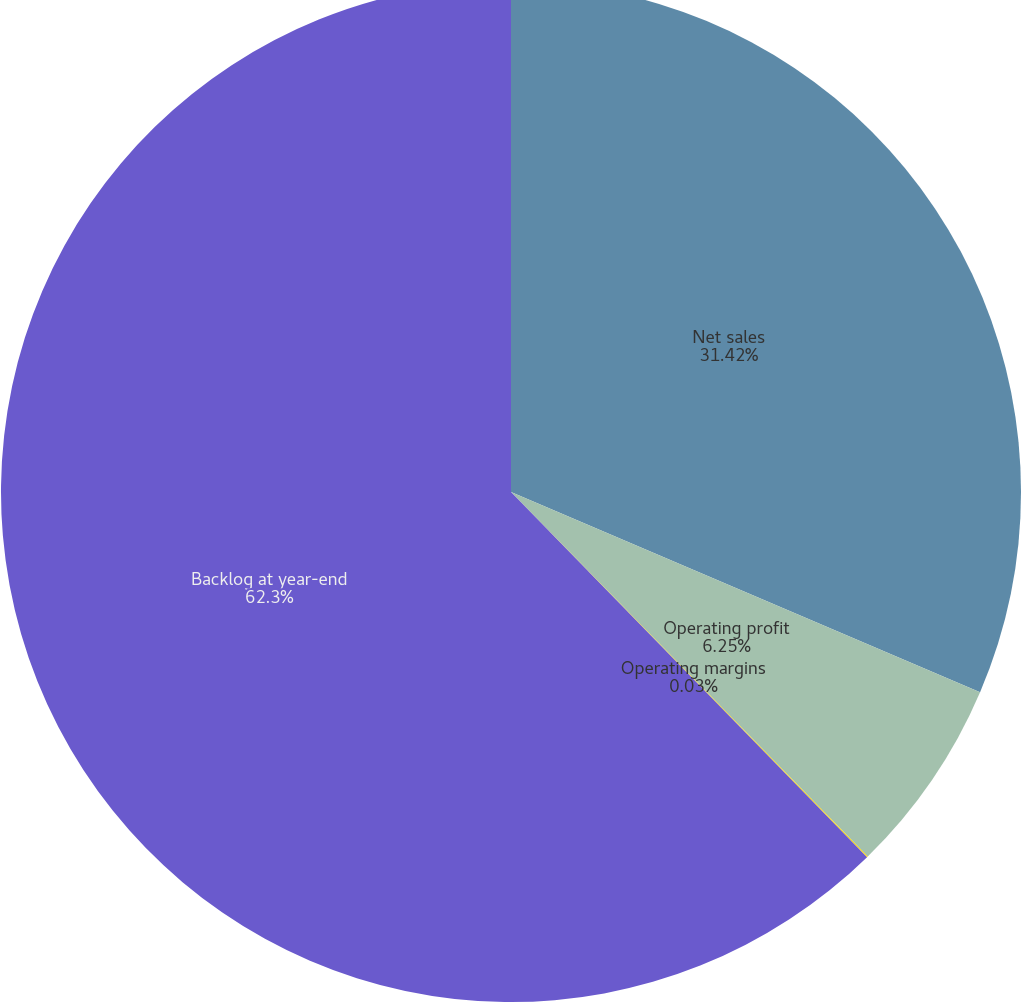Convert chart. <chart><loc_0><loc_0><loc_500><loc_500><pie_chart><fcel>Net sales<fcel>Operating profit<fcel>Operating margins<fcel>Backlog at year-end<nl><fcel>31.42%<fcel>6.25%<fcel>0.03%<fcel>62.3%<nl></chart> 